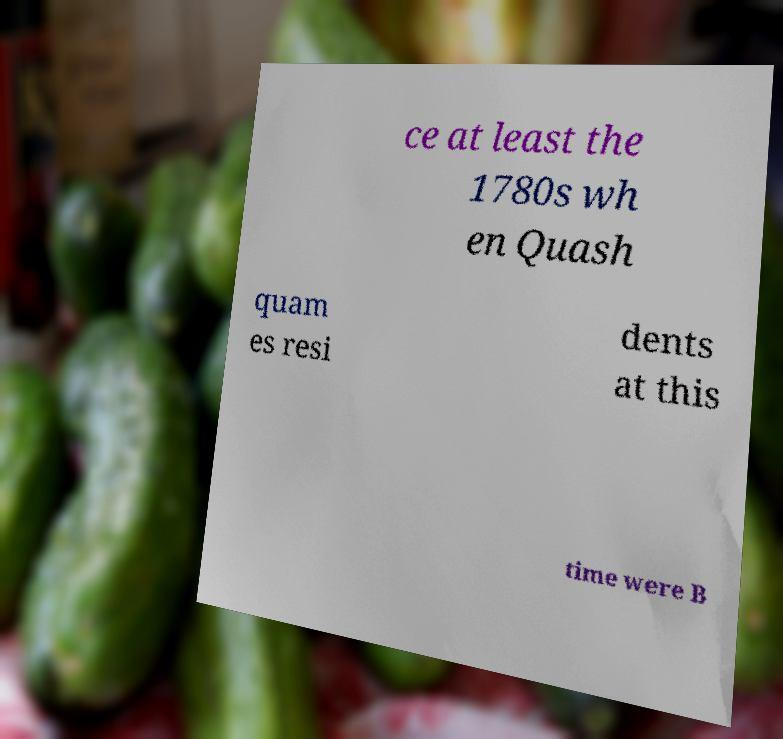Can you read and provide the text displayed in the image?This photo seems to have some interesting text. Can you extract and type it out for me? ce at least the 1780s wh en Quash quam es resi dents at this time were B 